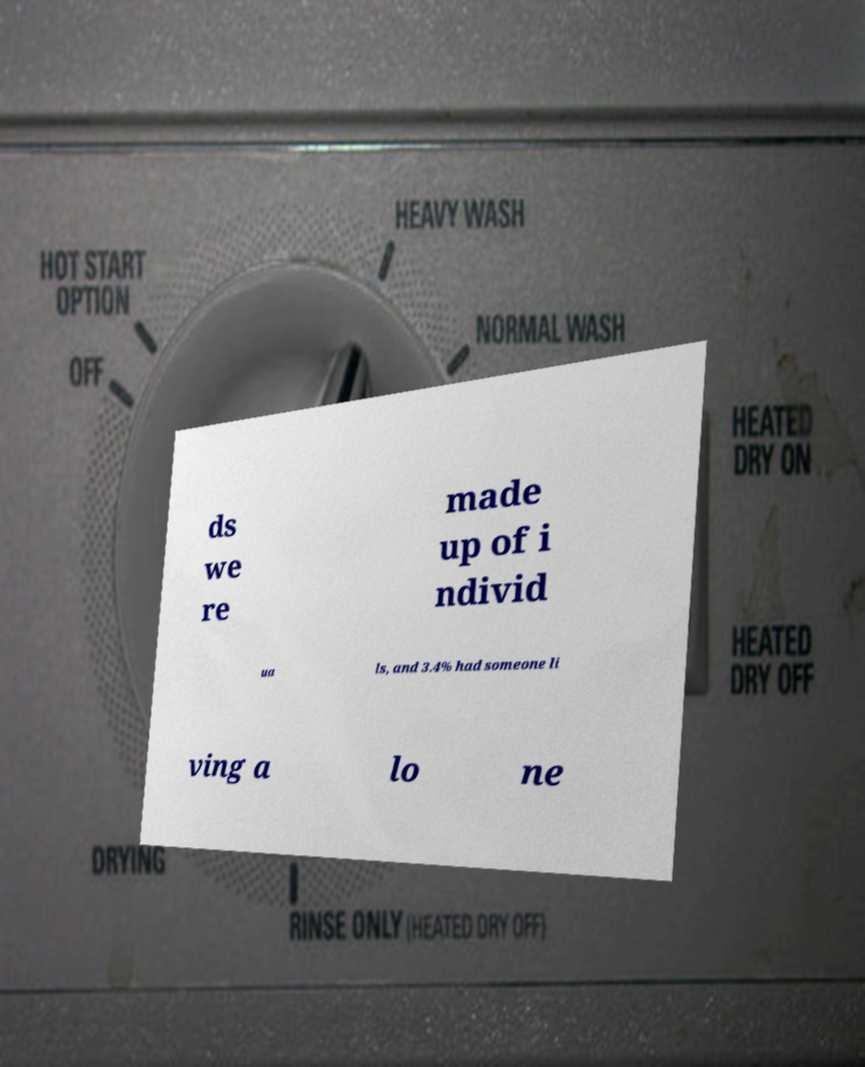Can you accurately transcribe the text from the provided image for me? ds we re made up of i ndivid ua ls, and 3.4% had someone li ving a lo ne 